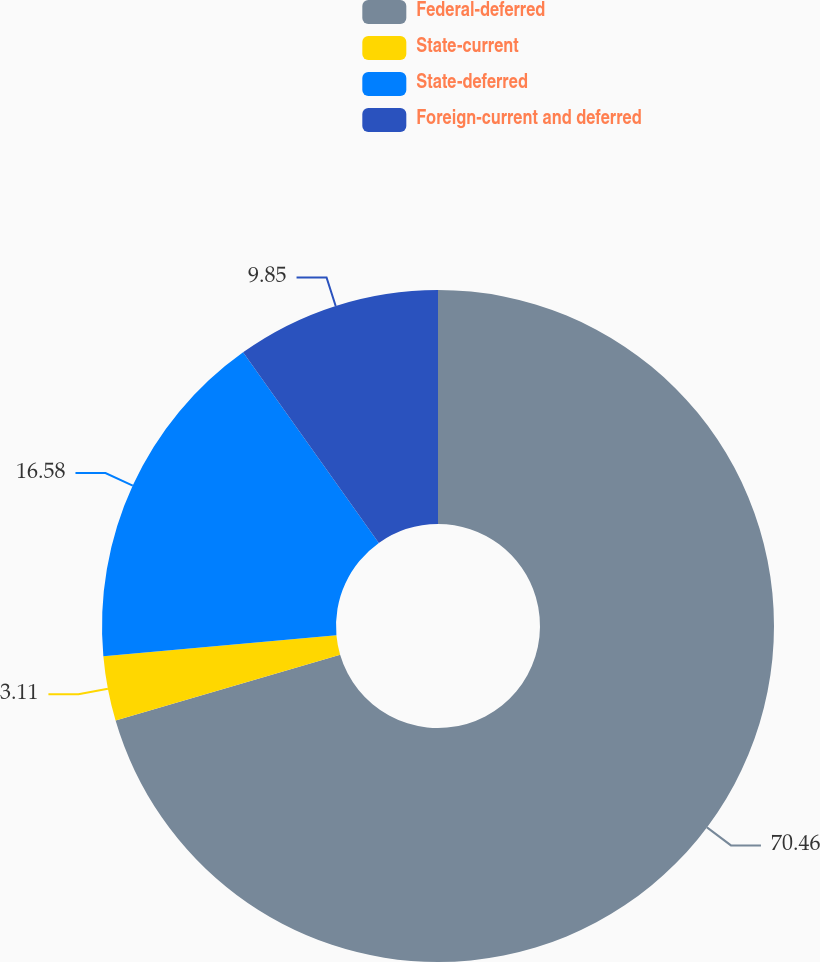Convert chart to OTSL. <chart><loc_0><loc_0><loc_500><loc_500><pie_chart><fcel>Federal-deferred<fcel>State-current<fcel>State-deferred<fcel>Foreign-current and deferred<nl><fcel>70.46%<fcel>3.11%<fcel>16.58%<fcel>9.85%<nl></chart> 